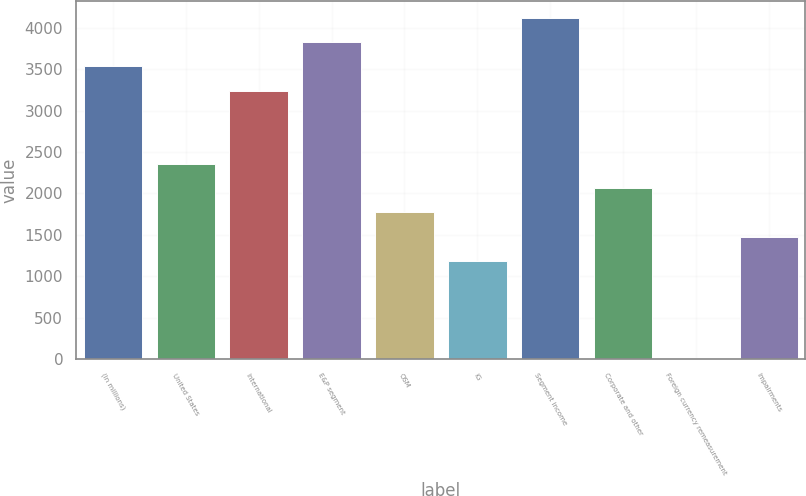Convert chart to OTSL. <chart><loc_0><loc_0><loc_500><loc_500><bar_chart><fcel>(In millions)<fcel>United States<fcel>International<fcel>E&P segment<fcel>OSM<fcel>IG<fcel>Segment income<fcel>Corporate and other<fcel>Foreign currency remeasurement<fcel>Impairments<nl><fcel>3533.4<fcel>2358.6<fcel>3239.7<fcel>3827.1<fcel>1771.2<fcel>1183.8<fcel>4120.8<fcel>2064.9<fcel>9<fcel>1477.5<nl></chart> 